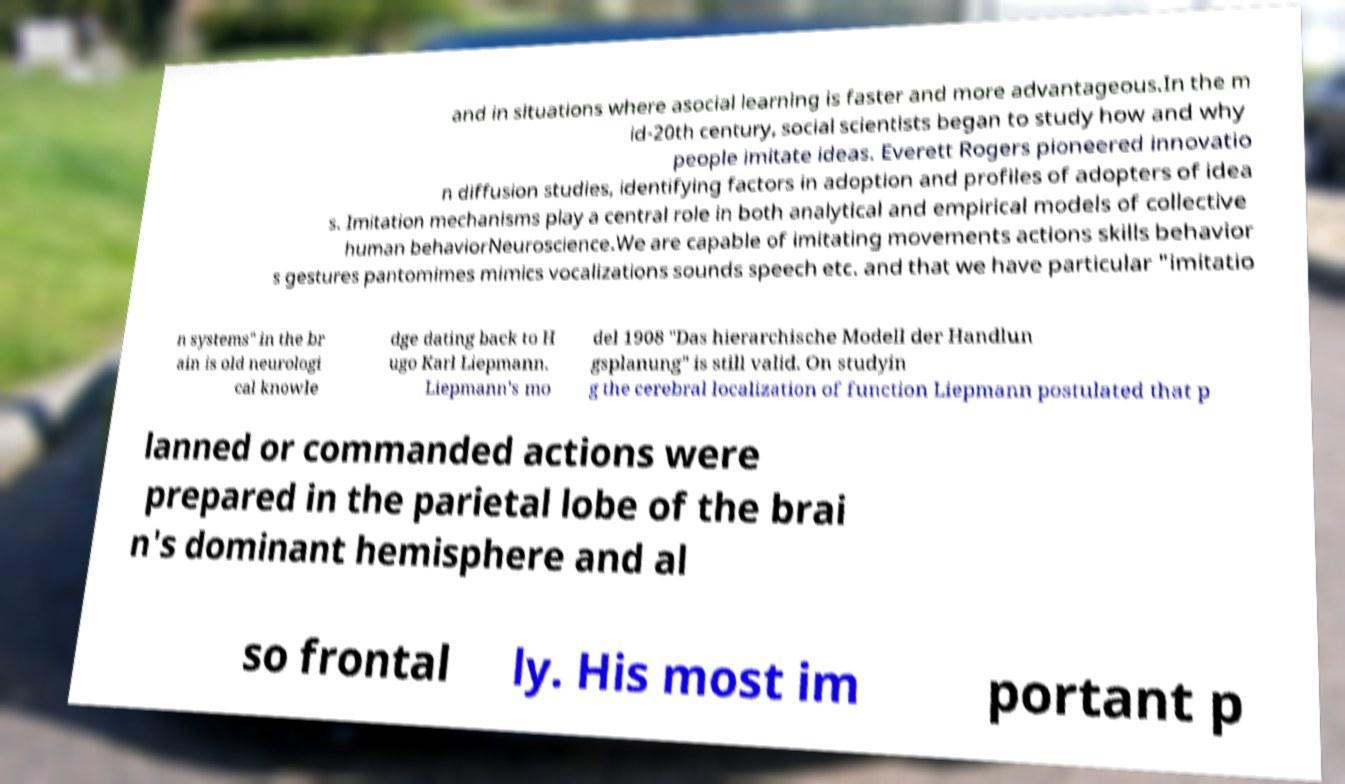There's text embedded in this image that I need extracted. Can you transcribe it verbatim? and in situations where asocial learning is faster and more advantageous.In the m id-20th century, social scientists began to study how and why people imitate ideas. Everett Rogers pioneered innovatio n diffusion studies, identifying factors in adoption and profiles of adopters of idea s. Imitation mechanisms play a central role in both analytical and empirical models of collective human behaviorNeuroscience.We are capable of imitating movements actions skills behavior s gestures pantomimes mimics vocalizations sounds speech etc. and that we have particular "imitatio n systems" in the br ain is old neurologi cal knowle dge dating back to H ugo Karl Liepmann. Liepmann's mo del 1908 "Das hierarchische Modell der Handlun gsplanung" is still valid. On studyin g the cerebral localization of function Liepmann postulated that p lanned or commanded actions were prepared in the parietal lobe of the brai n's dominant hemisphere and al so frontal ly. His most im portant p 